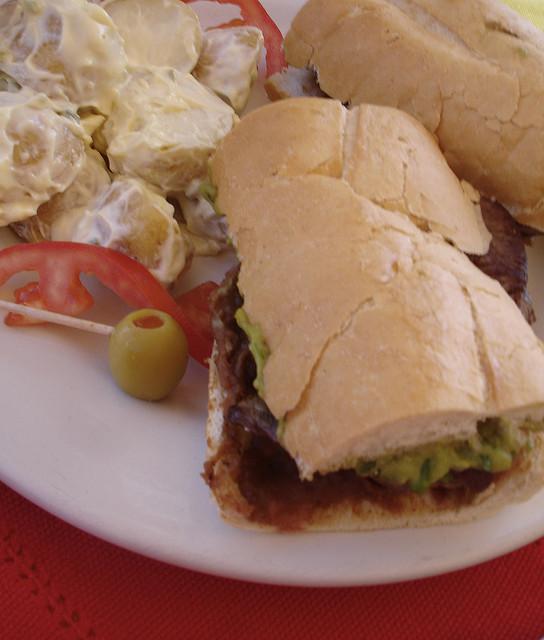What is the side dish on the plate?
Write a very short answer. Potato salad. Does the sandwich have tomatoes?
Write a very short answer. Yes. Is there a vegetable in this picture?
Short answer required. Yes. 